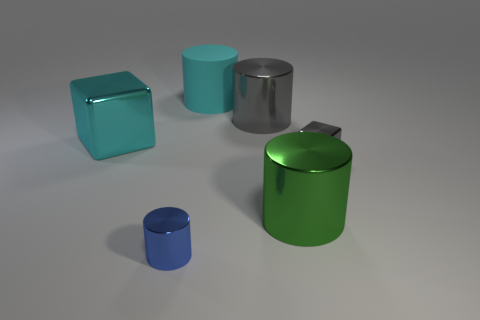How many other objects are the same material as the large gray cylinder?
Provide a succinct answer. 4. There is a cylinder that is both behind the small gray metallic cube and in front of the cyan matte cylinder; what color is it?
Your response must be concise. Gray. How many things are things in front of the small gray block or cyan cylinders?
Offer a very short reply. 3. How many other things are there of the same color as the tiny cylinder?
Keep it short and to the point. 0. Are there an equal number of cylinders that are behind the big metal block and big objects?
Your response must be concise. No. How many cyan rubber objects are right of the metal cylinder behind the cube that is to the right of the green shiny cylinder?
Keep it short and to the point. 0. Are there any other things that are the same size as the gray shiny block?
Provide a succinct answer. Yes. There is a rubber cylinder; is its size the same as the metal block right of the cyan matte cylinder?
Your answer should be very brief. No. What number of red cylinders are there?
Ensure brevity in your answer.  0. Do the metal thing behind the cyan cube and the metallic block that is to the left of the big rubber cylinder have the same size?
Your answer should be compact. Yes. 